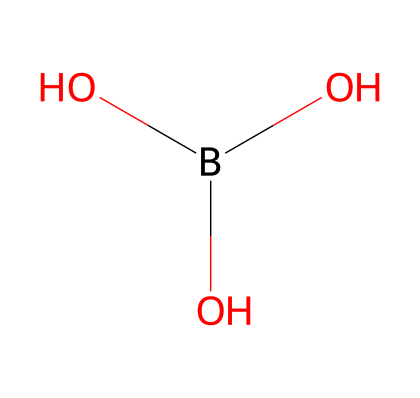What is the name of this chemical? The SMILES representation corresponds to a compound commonly known as boric acid, which is a well-studied natural fungicide.
Answer: boric acid How many oxygen atoms are in this molecule? By analyzing the SMILES representation, we can observe there are three oxygen atoms present in the structure.
Answer: three What type of bond is primarily found in boric acid? The chemical structure shows that boric acid primarily contains covalent bonds, where atoms share electrons.
Answer: covalent Which component allows boric acid to act as a fungicide? The hydroxyl (OH) groups in the structure are crucial for its antifungal properties, indicating how it interacts with fungal organisms.
Answer: hydroxyl groups What is the molecular formula for boric acid? The number of atoms and their respective types indicate that the molecular formula derived from the structure is H3BO3.
Answer: H3BO3 How does this chemical's structure contribute to its solubility? The presence of hydroxyl groups (OH), which are polar, contributes to the molecule's ability to dissolve in water, enhancing its usability for treatment.
Answer: polar hydroxyl groups 